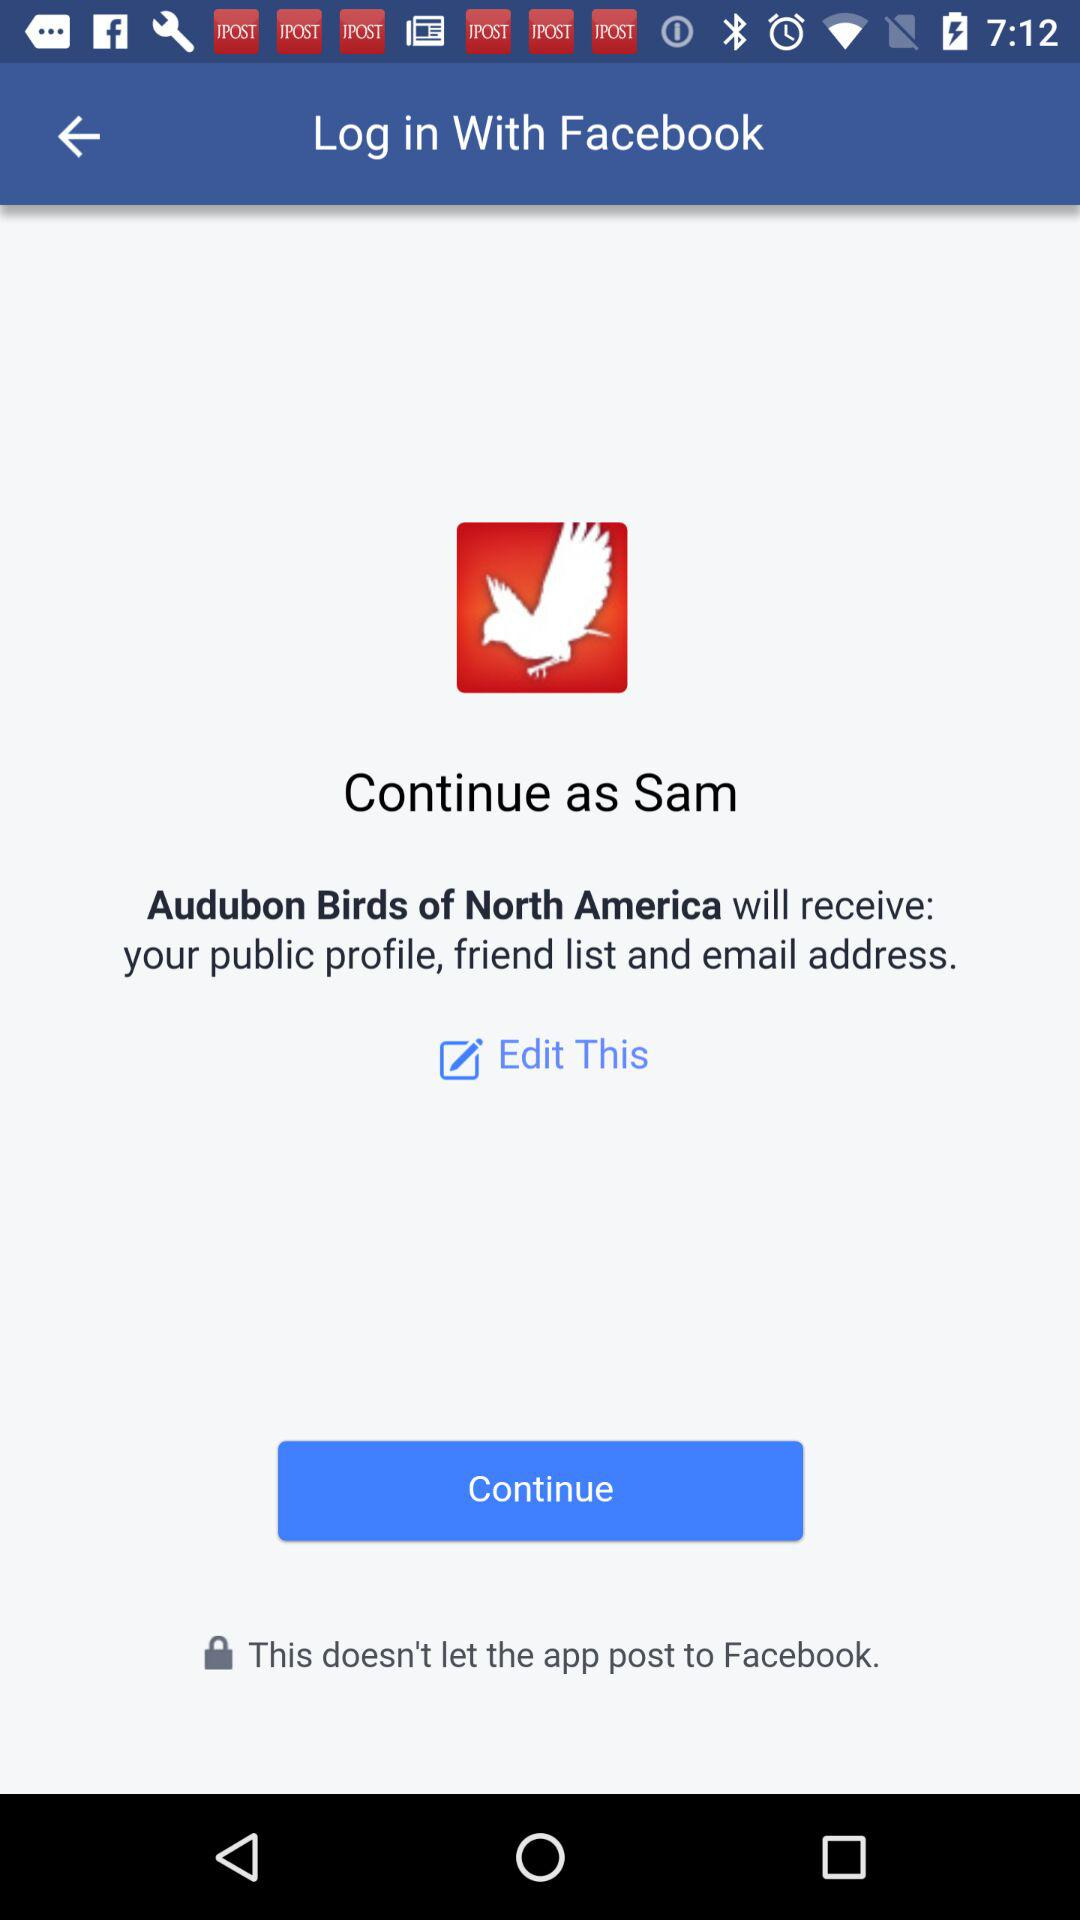What is the name of the user? The name of the user is Sam. 